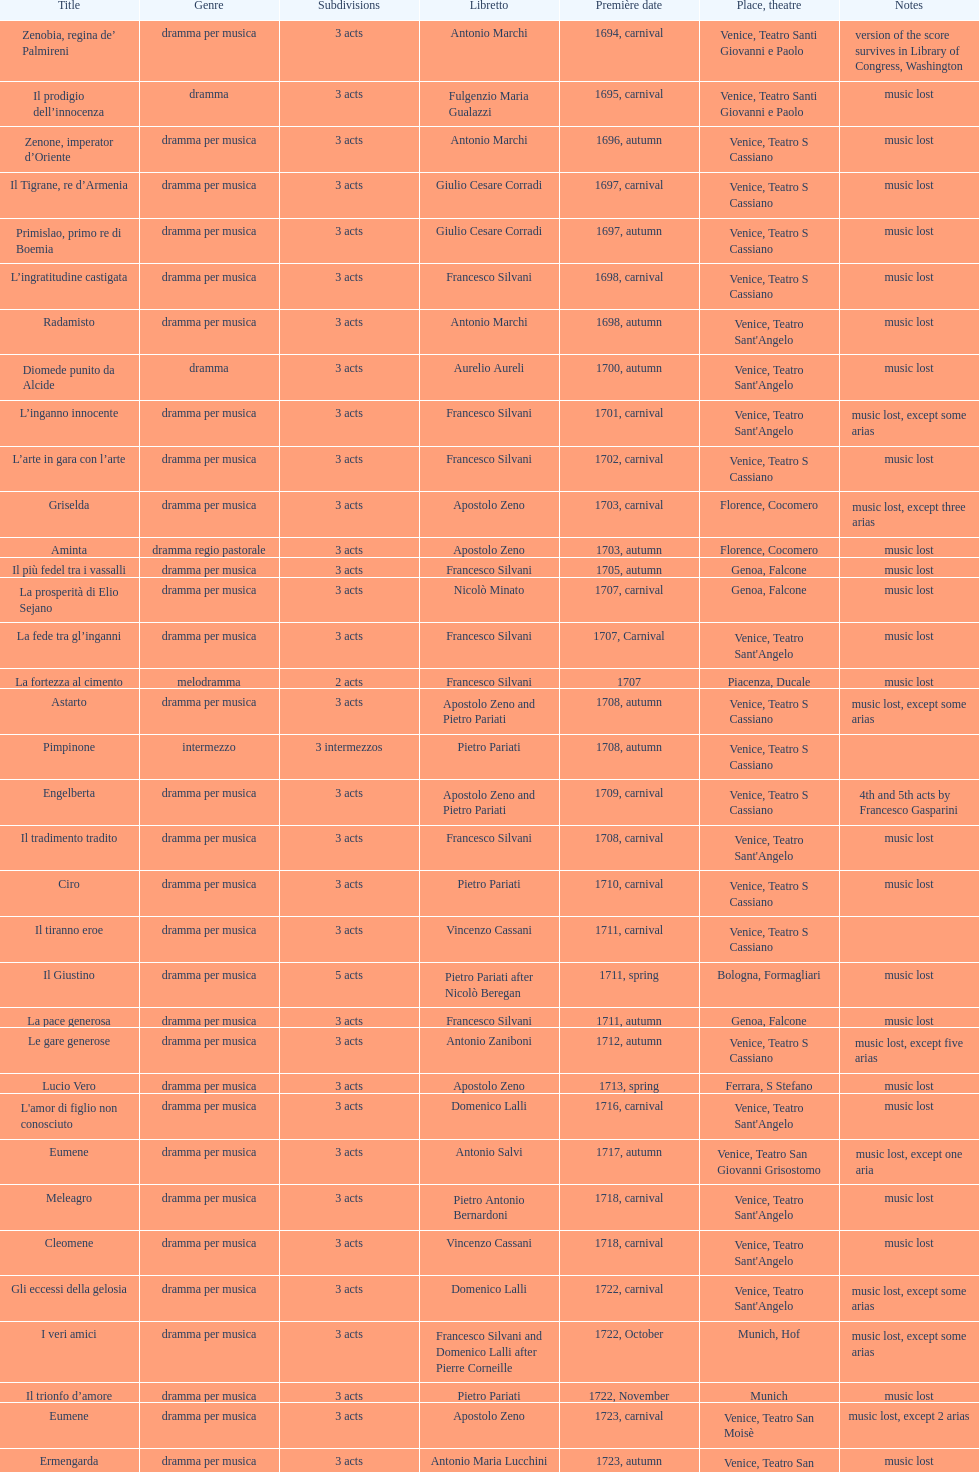How many were released after zenone, imperator d'oriente? 52. 